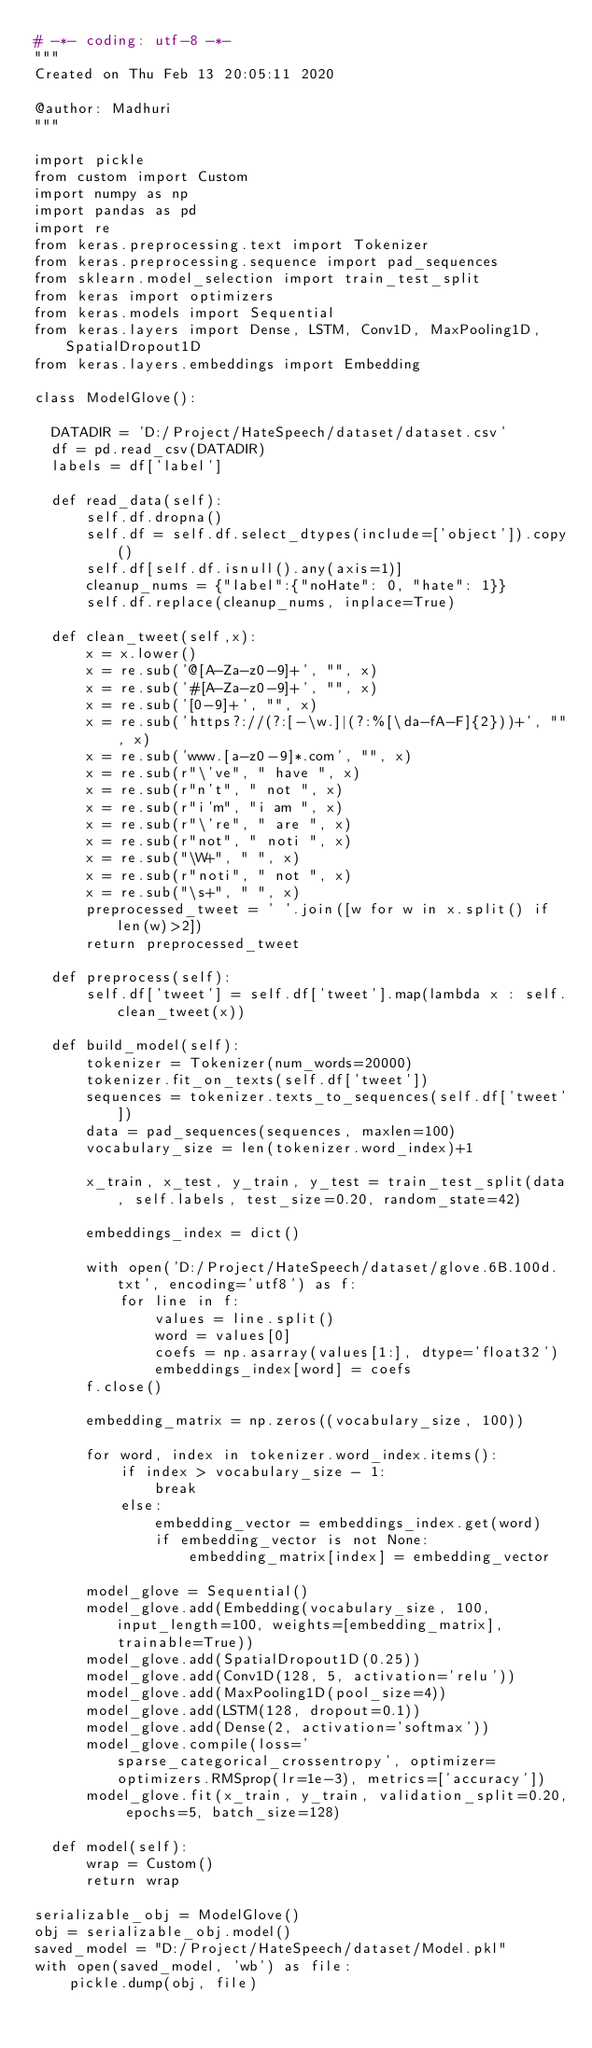Convert code to text. <code><loc_0><loc_0><loc_500><loc_500><_Python_># -*- coding: utf-8 -*-
"""
Created on Thu Feb 13 20:05:11 2020

@author: Madhuri
"""

import pickle
from custom import Custom
import numpy as np
import pandas as pd
import re
from keras.preprocessing.text import Tokenizer
from keras.preprocessing.sequence import pad_sequences
from sklearn.model_selection import train_test_split
from keras import optimizers
from keras.models import Sequential
from keras.layers import Dense, LSTM, Conv1D, MaxPooling1D, SpatialDropout1D
from keras.layers.embeddings import Embedding

class ModelGlove():
    
  DATADIR = 'D:/Project/HateSpeech/dataset/dataset.csv'
  df = pd.read_csv(DATADIR)
  labels = df['label']
  
  def read_data(self):
      self.df.dropna()
      self.df = self.df.select_dtypes(include=['object']).copy()
      self.df[self.df.isnull().any(axis=1)]
      cleanup_nums = {"label":{"noHate": 0, "hate": 1}}
      self.df.replace(cleanup_nums, inplace=True)  
    
  def clean_tweet(self,x):
      x = x.lower()
      x = re.sub('@[A-Za-z0-9]+', "", x)
      x = re.sub('#[A-Za-z0-9]+', "", x)
      x = re.sub('[0-9]+', "", x)
      x = re.sub('https?://(?:[-\w.]|(?:%[\da-fA-F]{2}))+', "", x)
      x = re.sub('www.[a-z0-9]*.com', "", x)
      x = re.sub(r"\'ve", " have ", x)
      x = re.sub(r"n't", " not ", x)
      x = re.sub(r"i'm", "i am ", x)
      x = re.sub(r"\'re", " are ", x)
      x = re.sub(r"not", " noti ", x)
      x = re.sub("\W+", " ", x)
      x = re.sub(r"noti", " not ", x)
      x = re.sub("\s+", " ", x)
      preprocessed_tweet = ' '.join([w for w in x.split() if len(w)>2])
      return preprocessed_tweet  

  def preprocess(self):
      self.df['tweet'] = self.df['tweet'].map(lambda x : self.clean_tweet(x))  

  def build_model(self):
      tokenizer = Tokenizer(num_words=20000)
      tokenizer.fit_on_texts(self.df['tweet'])
      sequences = tokenizer.texts_to_sequences(self.df['tweet'])
      data = pad_sequences(sequences, maxlen=100)
      vocabulary_size = len(tokenizer.word_index)+1
      
      x_train, x_test, y_train, y_test = train_test_split(data, self.labels, test_size=0.20, random_state=42)
      
      embeddings_index = dict()
      
      with open('D:/Project/HateSpeech/dataset/glove.6B.100d.txt', encoding='utf8') as f:
          for line in f:
              values = line.split()
              word = values[0]
              coefs = np.asarray(values[1:], dtype='float32')
              embeddings_index[word] = coefs
      f.close()
      
      embedding_matrix = np.zeros((vocabulary_size, 100))
      
      for word, index in tokenizer.word_index.items():
          if index > vocabulary_size - 1:
              break
          else:
              embedding_vector = embeddings_index.get(word)
              if embedding_vector is not None:
                  embedding_matrix[index] = embedding_vector
      
      model_glove = Sequential() 
      model_glove.add(Embedding(vocabulary_size, 100, input_length=100, weights=[embedding_matrix], trainable=True))
      model_glove.add(SpatialDropout1D(0.25))
      model_glove.add(Conv1D(128, 5, activation='relu'))
      model_glove.add(MaxPooling1D(pool_size=4))
      model_glove.add(LSTM(128, dropout=0.1))
      model_glove.add(Dense(2, activation='softmax'))
      model_glove.compile(loss='sparse_categorical_crossentropy', optimizer=optimizers.RMSprop(lr=1e-3), metrics=['accuracy'])
      model_glove.fit(x_train, y_train, validation_split=0.20, epochs=5, batch_size=128)

  def model(self):
      wrap = Custom()
      return wrap
      
serializable_obj = ModelGlove()
obj = serializable_obj.model()
saved_model = "D:/Project/HateSpeech/dataset/Model.pkl" 
with open(saved_model, 'wb') as file:  
    pickle.dump(obj, file)</code> 